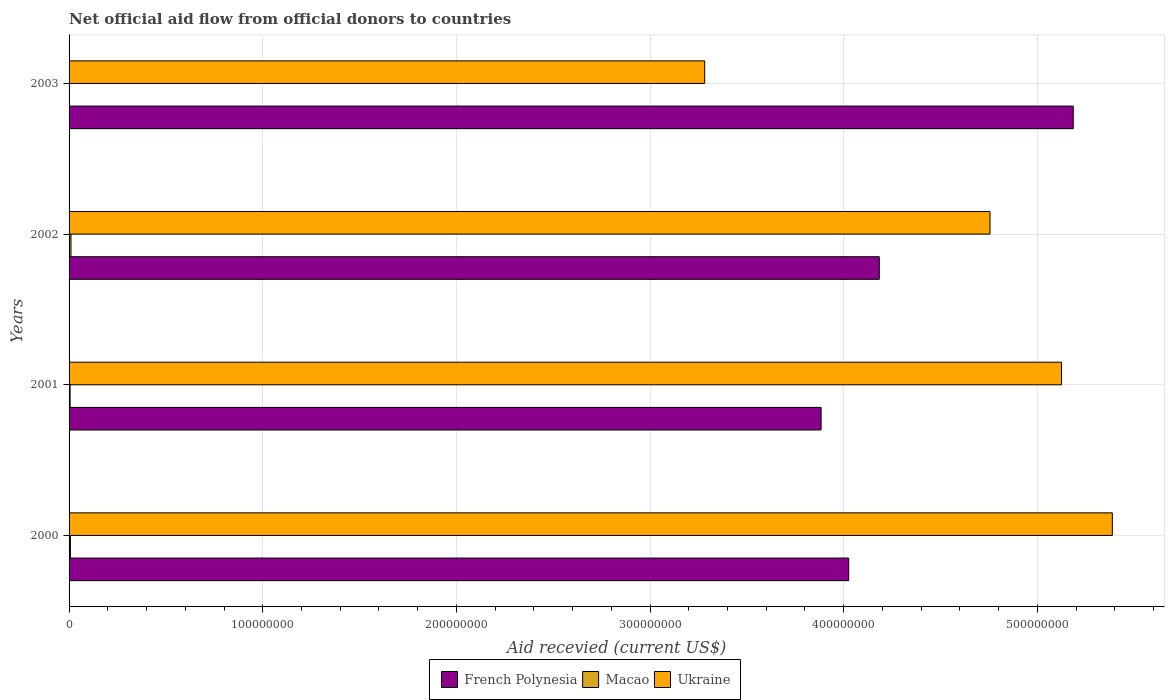How many different coloured bars are there?
Keep it short and to the point. 3. How many groups of bars are there?
Give a very brief answer. 4. Are the number of bars on each tick of the Y-axis equal?
Give a very brief answer. Yes. How many bars are there on the 4th tick from the bottom?
Provide a succinct answer. 3. What is the label of the 4th group of bars from the top?
Offer a very short reply. 2000. What is the total aid received in Macao in 2002?
Keep it short and to the point. 9.80e+05. Across all years, what is the maximum total aid received in Ukraine?
Provide a short and direct response. 5.39e+08. Across all years, what is the minimum total aid received in Ukraine?
Give a very brief answer. 3.28e+08. What is the total total aid received in Macao in the graph?
Give a very brief answer. 2.32e+06. What is the difference between the total aid received in French Polynesia in 2001 and the total aid received in Macao in 2003?
Provide a short and direct response. 3.88e+08. What is the average total aid received in Macao per year?
Offer a very short reply. 5.80e+05. In the year 2002, what is the difference between the total aid received in Macao and total aid received in Ukraine?
Your answer should be very brief. -4.75e+08. In how many years, is the total aid received in French Polynesia greater than 340000000 US$?
Provide a succinct answer. 4. What is the ratio of the total aid received in Ukraine in 2002 to that in 2003?
Your answer should be compact. 1.45. Is the total aid received in French Polynesia in 2000 less than that in 2001?
Your answer should be very brief. No. What is the difference between the highest and the second highest total aid received in French Polynesia?
Make the answer very short. 1.00e+08. What is the difference between the highest and the lowest total aid received in Macao?
Offer a terse response. 8.50e+05. In how many years, is the total aid received in French Polynesia greater than the average total aid received in French Polynesia taken over all years?
Make the answer very short. 1. Is the sum of the total aid received in Macao in 2001 and 2003 greater than the maximum total aid received in Ukraine across all years?
Your answer should be compact. No. What does the 3rd bar from the top in 2003 represents?
Your answer should be compact. French Polynesia. What does the 2nd bar from the bottom in 2003 represents?
Your answer should be very brief. Macao. Is it the case that in every year, the sum of the total aid received in Macao and total aid received in French Polynesia is greater than the total aid received in Ukraine?
Provide a succinct answer. No. Are all the bars in the graph horizontal?
Offer a terse response. Yes. How many years are there in the graph?
Provide a succinct answer. 4. Does the graph contain any zero values?
Keep it short and to the point. No. Does the graph contain grids?
Offer a terse response. Yes. What is the title of the graph?
Your answer should be very brief. Net official aid flow from official donors to countries. What is the label or title of the X-axis?
Keep it short and to the point. Aid recevied (current US$). What is the label or title of the Y-axis?
Your answer should be very brief. Years. What is the Aid recevied (current US$) of French Polynesia in 2000?
Your response must be concise. 4.03e+08. What is the Aid recevied (current US$) in Macao in 2000?
Your response must be concise. 6.80e+05. What is the Aid recevied (current US$) of Ukraine in 2000?
Offer a very short reply. 5.39e+08. What is the Aid recevied (current US$) of French Polynesia in 2001?
Provide a short and direct response. 3.88e+08. What is the Aid recevied (current US$) in Macao in 2001?
Ensure brevity in your answer.  5.30e+05. What is the Aid recevied (current US$) of Ukraine in 2001?
Your answer should be very brief. 5.12e+08. What is the Aid recevied (current US$) of French Polynesia in 2002?
Give a very brief answer. 4.18e+08. What is the Aid recevied (current US$) in Macao in 2002?
Keep it short and to the point. 9.80e+05. What is the Aid recevied (current US$) of Ukraine in 2002?
Your answer should be very brief. 4.76e+08. What is the Aid recevied (current US$) in French Polynesia in 2003?
Make the answer very short. 5.19e+08. What is the Aid recevied (current US$) in Ukraine in 2003?
Provide a succinct answer. 3.28e+08. Across all years, what is the maximum Aid recevied (current US$) in French Polynesia?
Keep it short and to the point. 5.19e+08. Across all years, what is the maximum Aid recevied (current US$) of Macao?
Offer a terse response. 9.80e+05. Across all years, what is the maximum Aid recevied (current US$) in Ukraine?
Ensure brevity in your answer.  5.39e+08. Across all years, what is the minimum Aid recevied (current US$) in French Polynesia?
Your answer should be very brief. 3.88e+08. Across all years, what is the minimum Aid recevied (current US$) of Ukraine?
Your answer should be very brief. 3.28e+08. What is the total Aid recevied (current US$) of French Polynesia in the graph?
Offer a terse response. 1.73e+09. What is the total Aid recevied (current US$) in Macao in the graph?
Your answer should be compact. 2.32e+06. What is the total Aid recevied (current US$) of Ukraine in the graph?
Provide a short and direct response. 1.85e+09. What is the difference between the Aid recevied (current US$) in French Polynesia in 2000 and that in 2001?
Your answer should be compact. 1.43e+07. What is the difference between the Aid recevied (current US$) in Ukraine in 2000 and that in 2001?
Your answer should be compact. 2.62e+07. What is the difference between the Aid recevied (current US$) in French Polynesia in 2000 and that in 2002?
Make the answer very short. -1.58e+07. What is the difference between the Aid recevied (current US$) of Macao in 2000 and that in 2002?
Provide a succinct answer. -3.00e+05. What is the difference between the Aid recevied (current US$) of Ukraine in 2000 and that in 2002?
Provide a short and direct response. 6.32e+07. What is the difference between the Aid recevied (current US$) in French Polynesia in 2000 and that in 2003?
Give a very brief answer. -1.16e+08. What is the difference between the Aid recevied (current US$) of Macao in 2000 and that in 2003?
Your answer should be very brief. 5.50e+05. What is the difference between the Aid recevied (current US$) of Ukraine in 2000 and that in 2003?
Keep it short and to the point. 2.10e+08. What is the difference between the Aid recevied (current US$) of French Polynesia in 2001 and that in 2002?
Your answer should be compact. -3.01e+07. What is the difference between the Aid recevied (current US$) in Macao in 2001 and that in 2002?
Provide a succinct answer. -4.50e+05. What is the difference between the Aid recevied (current US$) of Ukraine in 2001 and that in 2002?
Your response must be concise. 3.69e+07. What is the difference between the Aid recevied (current US$) in French Polynesia in 2001 and that in 2003?
Give a very brief answer. -1.30e+08. What is the difference between the Aid recevied (current US$) of Macao in 2001 and that in 2003?
Your response must be concise. 4.00e+05. What is the difference between the Aid recevied (current US$) of Ukraine in 2001 and that in 2003?
Give a very brief answer. 1.84e+08. What is the difference between the Aid recevied (current US$) of French Polynesia in 2002 and that in 2003?
Keep it short and to the point. -1.00e+08. What is the difference between the Aid recevied (current US$) in Macao in 2002 and that in 2003?
Your answer should be compact. 8.50e+05. What is the difference between the Aid recevied (current US$) of Ukraine in 2002 and that in 2003?
Keep it short and to the point. 1.47e+08. What is the difference between the Aid recevied (current US$) of French Polynesia in 2000 and the Aid recevied (current US$) of Macao in 2001?
Keep it short and to the point. 4.02e+08. What is the difference between the Aid recevied (current US$) of French Polynesia in 2000 and the Aid recevied (current US$) of Ukraine in 2001?
Offer a terse response. -1.10e+08. What is the difference between the Aid recevied (current US$) in Macao in 2000 and the Aid recevied (current US$) in Ukraine in 2001?
Offer a very short reply. -5.12e+08. What is the difference between the Aid recevied (current US$) in French Polynesia in 2000 and the Aid recevied (current US$) in Macao in 2002?
Make the answer very short. 4.02e+08. What is the difference between the Aid recevied (current US$) of French Polynesia in 2000 and the Aid recevied (current US$) of Ukraine in 2002?
Your answer should be very brief. -7.30e+07. What is the difference between the Aid recevied (current US$) in Macao in 2000 and the Aid recevied (current US$) in Ukraine in 2002?
Offer a very short reply. -4.75e+08. What is the difference between the Aid recevied (current US$) in French Polynesia in 2000 and the Aid recevied (current US$) in Macao in 2003?
Provide a short and direct response. 4.02e+08. What is the difference between the Aid recevied (current US$) of French Polynesia in 2000 and the Aid recevied (current US$) of Ukraine in 2003?
Offer a terse response. 7.44e+07. What is the difference between the Aid recevied (current US$) in Macao in 2000 and the Aid recevied (current US$) in Ukraine in 2003?
Your answer should be very brief. -3.28e+08. What is the difference between the Aid recevied (current US$) of French Polynesia in 2001 and the Aid recevied (current US$) of Macao in 2002?
Offer a terse response. 3.87e+08. What is the difference between the Aid recevied (current US$) of French Polynesia in 2001 and the Aid recevied (current US$) of Ukraine in 2002?
Give a very brief answer. -8.72e+07. What is the difference between the Aid recevied (current US$) in Macao in 2001 and the Aid recevied (current US$) in Ukraine in 2002?
Provide a succinct answer. -4.75e+08. What is the difference between the Aid recevied (current US$) of French Polynesia in 2001 and the Aid recevied (current US$) of Macao in 2003?
Provide a succinct answer. 3.88e+08. What is the difference between the Aid recevied (current US$) of French Polynesia in 2001 and the Aid recevied (current US$) of Ukraine in 2003?
Ensure brevity in your answer.  6.01e+07. What is the difference between the Aid recevied (current US$) of Macao in 2001 and the Aid recevied (current US$) of Ukraine in 2003?
Offer a very short reply. -3.28e+08. What is the difference between the Aid recevied (current US$) in French Polynesia in 2002 and the Aid recevied (current US$) in Macao in 2003?
Make the answer very short. 4.18e+08. What is the difference between the Aid recevied (current US$) of French Polynesia in 2002 and the Aid recevied (current US$) of Ukraine in 2003?
Keep it short and to the point. 9.02e+07. What is the difference between the Aid recevied (current US$) in Macao in 2002 and the Aid recevied (current US$) in Ukraine in 2003?
Make the answer very short. -3.27e+08. What is the average Aid recevied (current US$) in French Polynesia per year?
Give a very brief answer. 4.32e+08. What is the average Aid recevied (current US$) in Macao per year?
Give a very brief answer. 5.80e+05. What is the average Aid recevied (current US$) in Ukraine per year?
Make the answer very short. 4.64e+08. In the year 2000, what is the difference between the Aid recevied (current US$) in French Polynesia and Aid recevied (current US$) in Macao?
Your answer should be compact. 4.02e+08. In the year 2000, what is the difference between the Aid recevied (current US$) in French Polynesia and Aid recevied (current US$) in Ukraine?
Your response must be concise. -1.36e+08. In the year 2000, what is the difference between the Aid recevied (current US$) in Macao and Aid recevied (current US$) in Ukraine?
Offer a terse response. -5.38e+08. In the year 2001, what is the difference between the Aid recevied (current US$) of French Polynesia and Aid recevied (current US$) of Macao?
Ensure brevity in your answer.  3.88e+08. In the year 2001, what is the difference between the Aid recevied (current US$) in French Polynesia and Aid recevied (current US$) in Ukraine?
Offer a terse response. -1.24e+08. In the year 2001, what is the difference between the Aid recevied (current US$) in Macao and Aid recevied (current US$) in Ukraine?
Make the answer very short. -5.12e+08. In the year 2002, what is the difference between the Aid recevied (current US$) in French Polynesia and Aid recevied (current US$) in Macao?
Ensure brevity in your answer.  4.17e+08. In the year 2002, what is the difference between the Aid recevied (current US$) in French Polynesia and Aid recevied (current US$) in Ukraine?
Offer a very short reply. -5.72e+07. In the year 2002, what is the difference between the Aid recevied (current US$) of Macao and Aid recevied (current US$) of Ukraine?
Provide a short and direct response. -4.75e+08. In the year 2003, what is the difference between the Aid recevied (current US$) of French Polynesia and Aid recevied (current US$) of Macao?
Your answer should be very brief. 5.18e+08. In the year 2003, what is the difference between the Aid recevied (current US$) of French Polynesia and Aid recevied (current US$) of Ukraine?
Your answer should be compact. 1.90e+08. In the year 2003, what is the difference between the Aid recevied (current US$) in Macao and Aid recevied (current US$) in Ukraine?
Ensure brevity in your answer.  -3.28e+08. What is the ratio of the Aid recevied (current US$) of French Polynesia in 2000 to that in 2001?
Offer a terse response. 1.04. What is the ratio of the Aid recevied (current US$) in Macao in 2000 to that in 2001?
Provide a succinct answer. 1.28. What is the ratio of the Aid recevied (current US$) of Ukraine in 2000 to that in 2001?
Your answer should be very brief. 1.05. What is the ratio of the Aid recevied (current US$) of French Polynesia in 2000 to that in 2002?
Give a very brief answer. 0.96. What is the ratio of the Aid recevied (current US$) in Macao in 2000 to that in 2002?
Offer a terse response. 0.69. What is the ratio of the Aid recevied (current US$) in Ukraine in 2000 to that in 2002?
Provide a succinct answer. 1.13. What is the ratio of the Aid recevied (current US$) in French Polynesia in 2000 to that in 2003?
Provide a short and direct response. 0.78. What is the ratio of the Aid recevied (current US$) of Macao in 2000 to that in 2003?
Your response must be concise. 5.23. What is the ratio of the Aid recevied (current US$) in Ukraine in 2000 to that in 2003?
Your answer should be very brief. 1.64. What is the ratio of the Aid recevied (current US$) in French Polynesia in 2001 to that in 2002?
Offer a very short reply. 0.93. What is the ratio of the Aid recevied (current US$) in Macao in 2001 to that in 2002?
Offer a terse response. 0.54. What is the ratio of the Aid recevied (current US$) of Ukraine in 2001 to that in 2002?
Your answer should be compact. 1.08. What is the ratio of the Aid recevied (current US$) in French Polynesia in 2001 to that in 2003?
Provide a short and direct response. 0.75. What is the ratio of the Aid recevied (current US$) in Macao in 2001 to that in 2003?
Provide a short and direct response. 4.08. What is the ratio of the Aid recevied (current US$) in Ukraine in 2001 to that in 2003?
Provide a short and direct response. 1.56. What is the ratio of the Aid recevied (current US$) of French Polynesia in 2002 to that in 2003?
Offer a terse response. 0.81. What is the ratio of the Aid recevied (current US$) in Macao in 2002 to that in 2003?
Offer a terse response. 7.54. What is the ratio of the Aid recevied (current US$) of Ukraine in 2002 to that in 2003?
Ensure brevity in your answer.  1.45. What is the difference between the highest and the second highest Aid recevied (current US$) of French Polynesia?
Offer a very short reply. 1.00e+08. What is the difference between the highest and the second highest Aid recevied (current US$) of Macao?
Your response must be concise. 3.00e+05. What is the difference between the highest and the second highest Aid recevied (current US$) of Ukraine?
Make the answer very short. 2.62e+07. What is the difference between the highest and the lowest Aid recevied (current US$) of French Polynesia?
Give a very brief answer. 1.30e+08. What is the difference between the highest and the lowest Aid recevied (current US$) of Macao?
Your answer should be compact. 8.50e+05. What is the difference between the highest and the lowest Aid recevied (current US$) of Ukraine?
Give a very brief answer. 2.10e+08. 